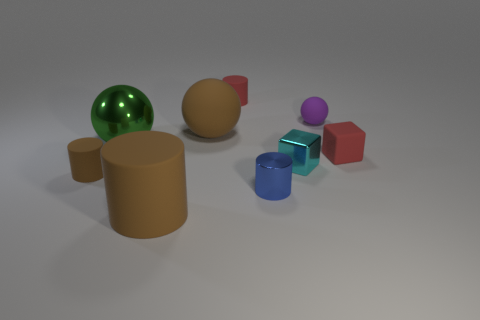Add 1 small blue cylinders. How many objects exist? 10 Subtract all green metallic balls. How many balls are left? 2 Add 9 small metallic spheres. How many small metallic spheres exist? 9 Subtract all purple balls. How many balls are left? 2 Subtract 0 brown cubes. How many objects are left? 9 Subtract all cylinders. How many objects are left? 5 Subtract 2 spheres. How many spheres are left? 1 Subtract all red cubes. Subtract all yellow balls. How many cubes are left? 1 Subtract all yellow balls. How many cyan cubes are left? 1 Subtract all tiny purple rubber blocks. Subtract all big rubber cylinders. How many objects are left? 8 